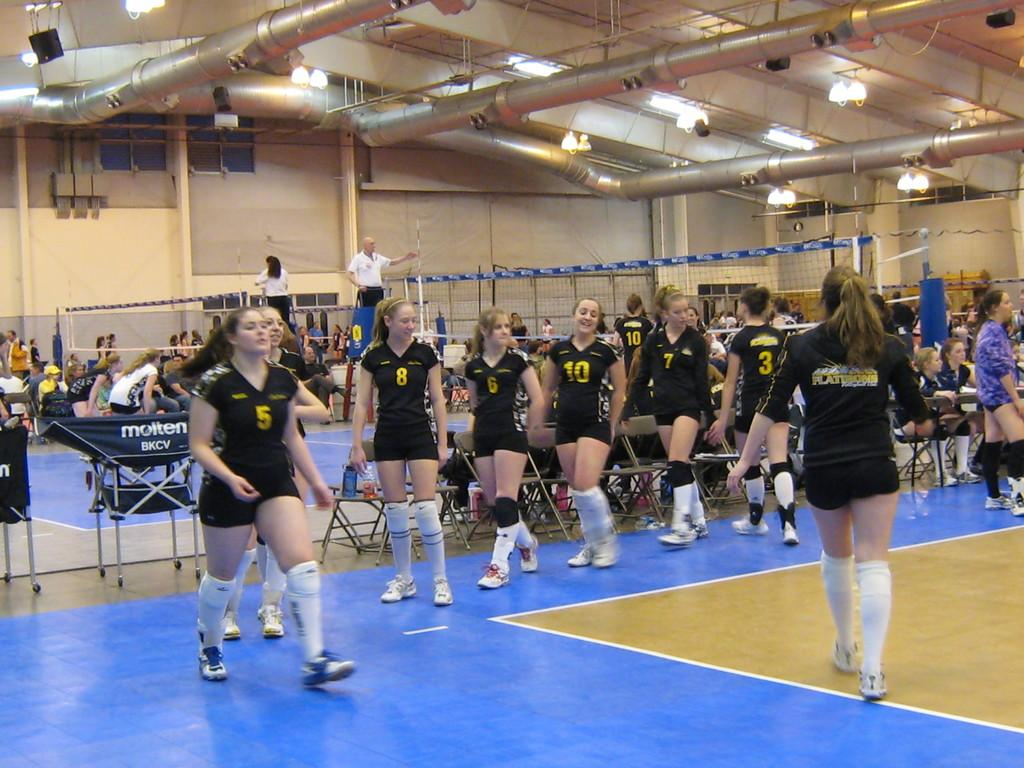<image>
Relay a brief, clear account of the picture shown. Several young females on the Flattrons team are in a gym. 